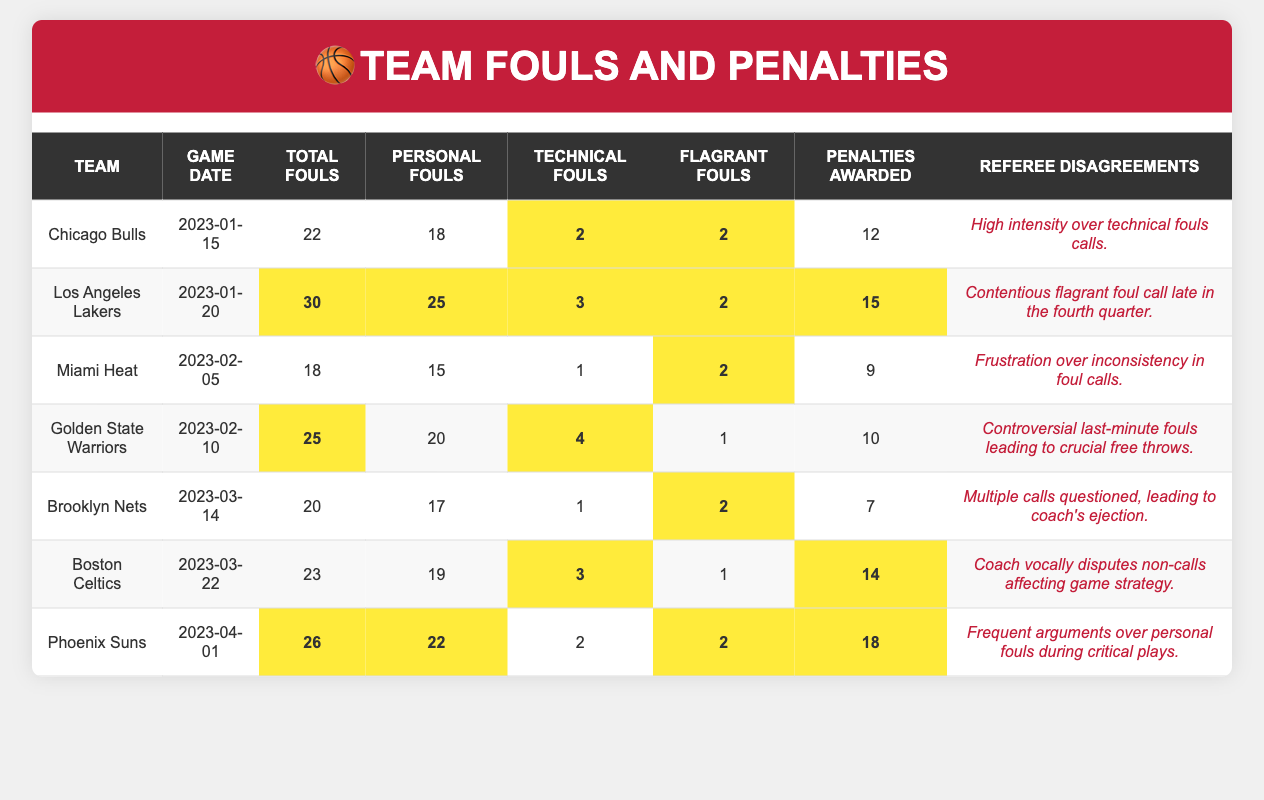What team committed the most total fouls? By reviewing the total fouls column, the Los Angeles Lakers have the highest count at 30 fouls, compared to other teams.
Answer: Los Angeles Lakers How many technical fouls were committed by the Golden State Warriors? The table shows that the Golden State Warriors committed 4 technical fouls in their game.
Answer: 4 What is the difference in penalties awarded between the Chicago Bulls and Miami Heat? The Chicago Bulls were awarded 12 penalties while the Miami Heat were awarded 9. The difference is 12 - 9 = 3 penalties.
Answer: 3 Did the Brooklyn Nets receive more penalties than the Boston Celtics? The Brooklyn Nets received 7 penalties and the Boston Celtics received 14 penalties, so they did not receive more penalties.
Answer: No Which team had the highest number of personal fouls in one game? By looking at the personal fouls column, the Los Angeles Lakers had the highest with 25 personal fouls.
Answer: Los Angeles Lakers How many teams had more than 20 total fouls? The table shows four teams (Los Angeles Lakers, Golden State Warriors, Phoenix Suns) that committed more than 20 total fouls in their games.
Answer: 4 What percentage of penalties awarded did the Miami Heat receive compared to their total fouls committed? The Miami Heat received 9 penalties out of their total 18 fouls, leading to a percentage of (9/18) * 100 = 50%.
Answer: 50% Were there any instances of a team having both technical and flagrant fouls in the same game? Yes, the Chicago Bulls, Los Angeles Lakers, and Phoenix Suns all recorded both technical and flagrant fouls in their respective games.
Answer: Yes What is the average total fouls committed by the teams listed? To calculate the average, sum the total fouls (22 + 30 + 18 + 25 + 20 + 23 + 26 = 174) and divide by the number of teams (7), giving an average of 174 / 7 ≈ 24.857, which rounds to 25.
Answer: 25 How did the referee disagreements differ among teams? Reviewing the disagreements, each team had varying levels of complaints; some related to technical fouls, while others concerned inconsistency or specific calls. Each entry provides unique feedback about refereeing that reflects the game situations.
Answer: Varies by team 